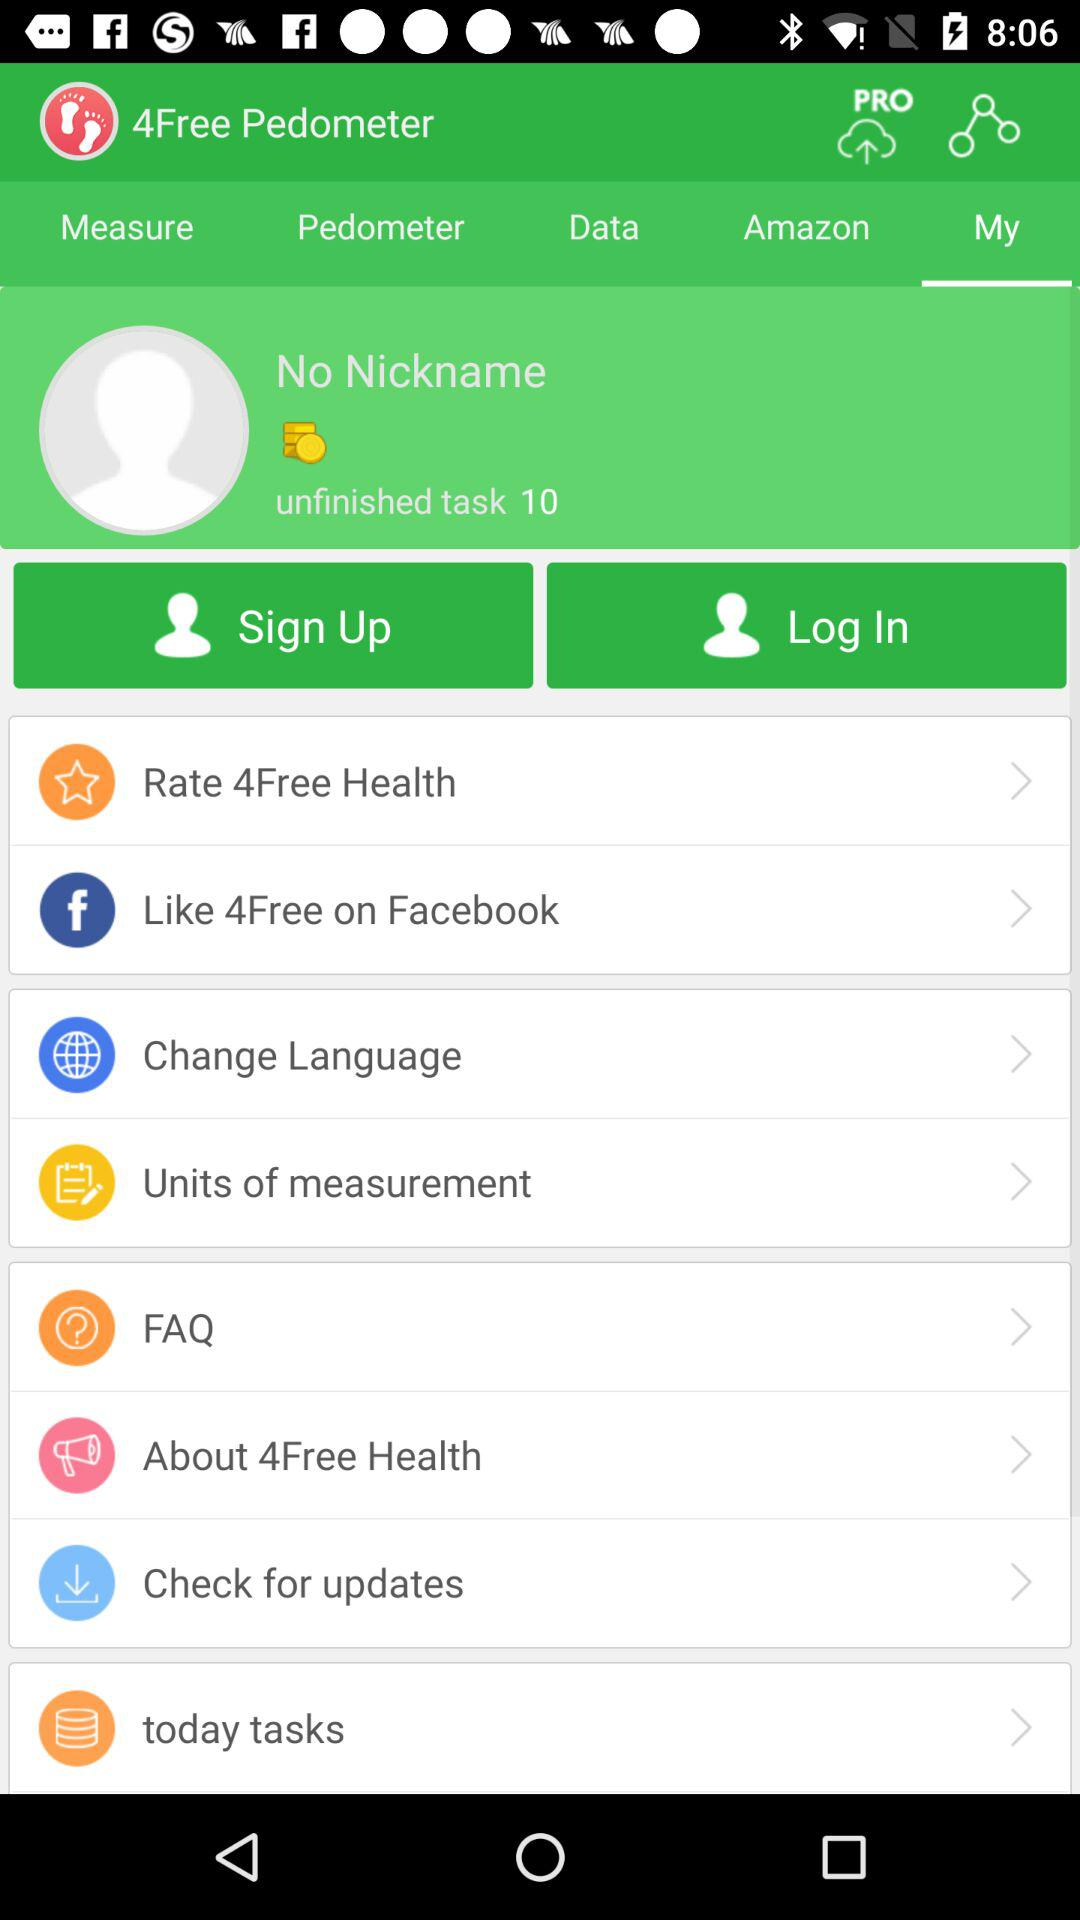Which tab is selected? The selected tab is "My". 